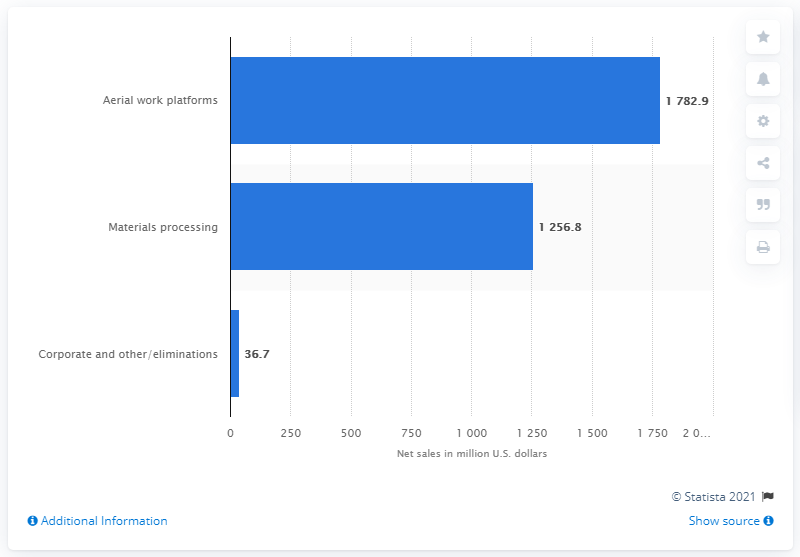Mention a couple of crucial points in this snapshot. In the fiscal year of 2020, the corporate and other/eliminations segment of Terex Corporation contributed 36.7 to the company's overall financial performance. 